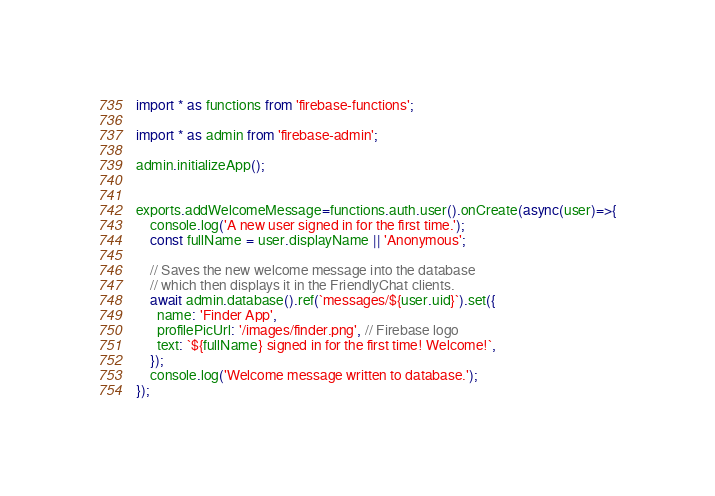Convert code to text. <code><loc_0><loc_0><loc_500><loc_500><_TypeScript_>import * as functions from 'firebase-functions';

import * as admin from 'firebase-admin';

admin.initializeApp();


exports.addWelcomeMessage=functions.auth.user().onCreate(async(user)=>{
    console.log('A new user signed in for the first time.');
    const fullName = user.displayName || 'Anonymous';
  
    // Saves the new welcome message into the database
    // which then displays it in the FriendlyChat clients.
    await admin.database().ref(`messages/${user.uid}`).set({
      name: 'Finder App',
      profilePicUrl: '/images/finder.png', // Firebase logo
      text: `${fullName} signed in for the first time! Welcome!`,
    });
    console.log('Welcome message written to database.');
});</code> 